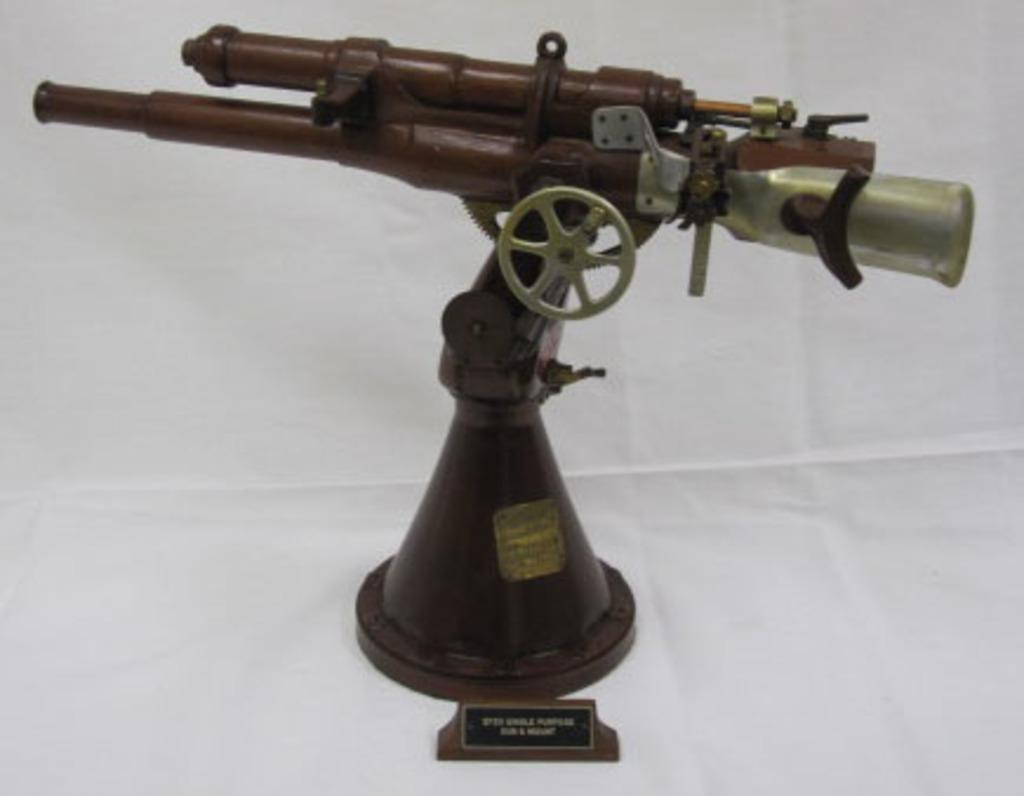What is the main subject of the image? The main subject of the image is a model of a weapon. How is the weapon positioned in the image? The weapon is fixed to a stand in the image. What is the color of the weapon? The weapon is in brown color. What is the color of the surface on which the weapon is placed? The weapon is placed on a white color surface. What is the name of the person holding the weapon in the image? There is no person holding the weapon in the image; it is fixed to a stand. Can you tell me the relationship between the weapon and the person's aunt in the image? There is no person or their aunt present in the image; it only features a model of a weapon fixed to a stand. 